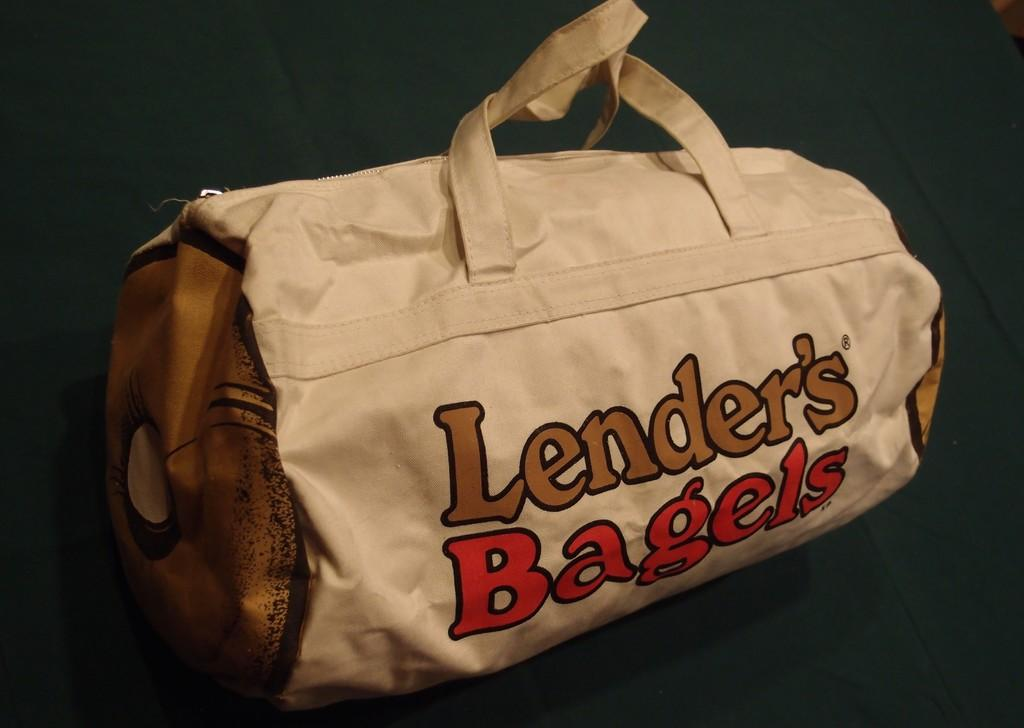What color is the handbag in the image? The handbag in the image is white. What color is the background of the handbag? The background of the handbag is green. What text is written on the handbag? The text "lender's bagels" is written on the handbag. How does the crowd affect the pain in the toe of the person holding the handbag in the image? There is no crowd or person holding the handbag in the image, and therefore no pain in the toe can be observed. 